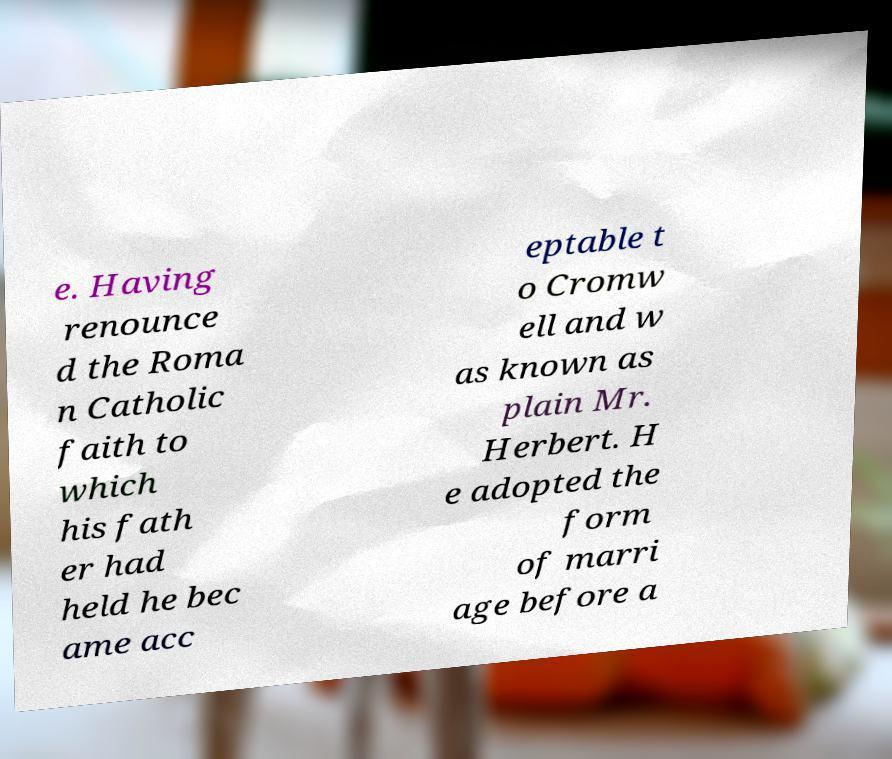For documentation purposes, I need the text within this image transcribed. Could you provide that? e. Having renounce d the Roma n Catholic faith to which his fath er had held he bec ame acc eptable t o Cromw ell and w as known as plain Mr. Herbert. H e adopted the form of marri age before a 